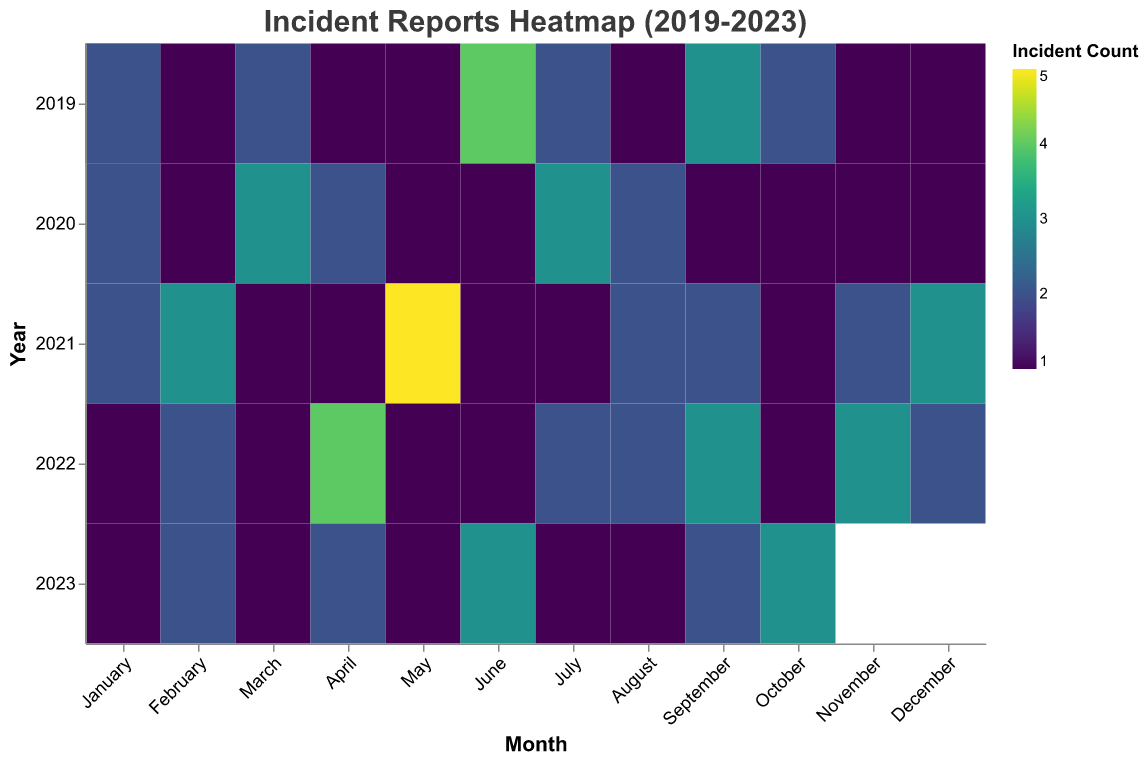What's the title of the heatmap? The title is located at the top center of the heatmap. It provides an overview of what the heatmap represents.
Answer: Incident Reports Heatmap (2019-2023) Which month had the highest number of incidents in 2021? To find this, observe each month's cell in the row corresponding to 2021 and identify the cell with the highest intensity color.
Answer: May How many high-severity chemical spills were there in total over the five years? Locate the cells where the 'Cause' is 'Chemical Spill' and 'Severity' is 'High'. Sum the 'IncidentCount' values from these cells. 2019 (1), 2020 (1), 2021 (2), 2022 (2).
Answer: 6 Which year had the lowest number of incidents involving "Fire"? Look at the cells corresponding to "Fire" across each year and count the total incidents. Compare these sums.
Answer: 2022 How do incident counts in June 2020 compare to June 2019 for "Chemical Spill"? Identify the cells for June in both 2019 and 2020 with the cause "Chemical Spill". Compare their 'IncidentCount' values. 2019 (4), 2020 (3).
Answer: 2019 had more incidents What's the average incident count for "Human Error" in 2020? Locate all cells in 2020 with the cause "Human Error". Add their 'IncidentCount' values and divide by the number of cells. January (2), May (1), October (1). Total = 4 incidents, 3 months.
Answer: 1.33 incidents Which cause had the most medium-severity incidents in 2021? Check the cells from 2021 where the 'Severity' is 'Medium' and compare the incident counts for each 'Cause'.
Answer: Chemical Spill Compare the total incidents due to "Equipment Malfunction" in January across all years. Sum the incident counts for "Equipment Malfunction" in January for each year from 2019 to 2023. 2019 (2), 2021 (2).
Answer: 4 incidents Are there any months with no incidents reported in any year? Scan all rows and columns to see if any cells are empty.
Answer: No, all months have at least one incident What's the trend of high-severity incidents over the years? Note the total number of high-severity incidents for each year and see if the counts are increasing, decreasing, or stable.
Answer: Variable with no clear trend 